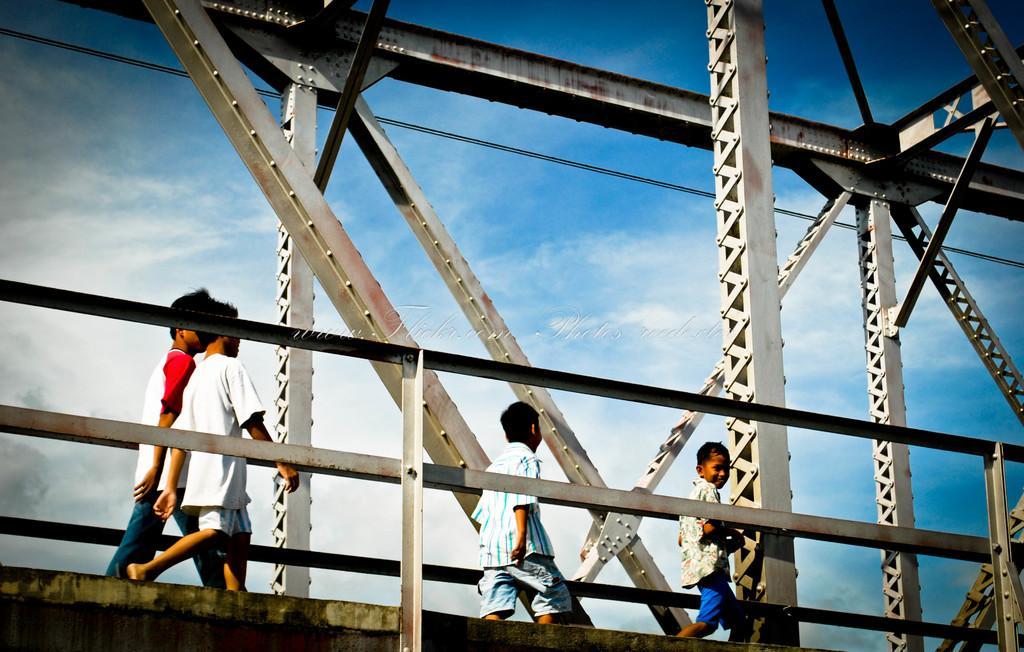Can you describe this image briefly? In this picture I can see a bridge and few boys walking on the bridge and a blue cloudy sky. 